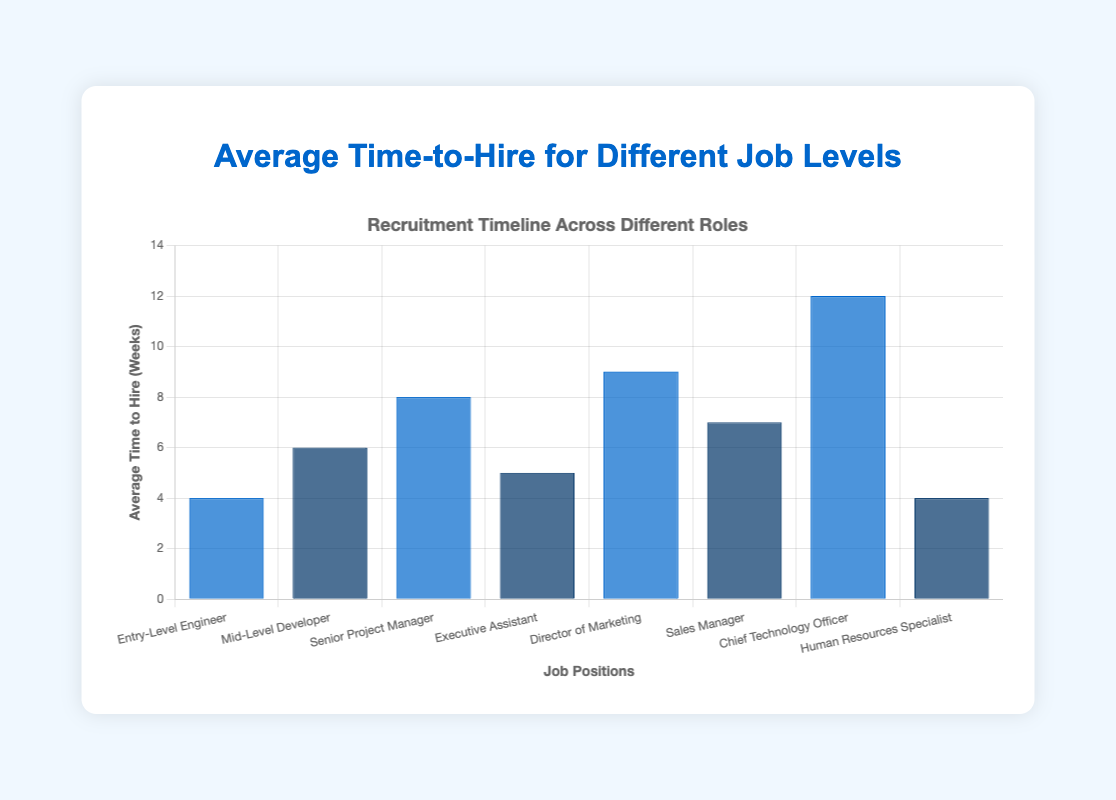What job level has the shortest average time-to-hire? The shortest average time-to-hire can be determined by identifying the job level with the smallest bar. "Entry-Level Engineer" and "Human Resources Specialist" both have the shortest average time-to-hire of 4 weeks.
Answer: Entry-Level Engineer, Human Resources Specialist Which job level has the longest average time-to-hire? The longest average time-to-hire can be determined by identifying the job level with the tallest bar. "Chief Technology Officer" has the longest average time-to-hire of 12 weeks.
Answer: Chief Technology Officer What is the average time-to-hire for the Senior Project Manager role? To find the average time-to-hire for the Senior Project Manager role, look at the height of the corresponding bar. The average time-to-hire for this role is 8 weeks.
Answer: 8 weeks Between the Executive Assistant and Director of Marketing, which role takes longer to hire? Compare the heights of the bars for Executive Assistant and Director of Marketing. The Director of Marketing takes longer to hire at 9 weeks, compared to the Executive Assistant at 5 weeks.
Answer: Director of Marketing What is the total time-to-hire for all the job levels combined? Sum the average time-to-hire for all job levels: 4 (Entry-Level Engineer) + 6 (Mid-Level Developer) + 8 (Senior Project Manager) + 5 (Executive Assistant) + 9 (Director of Marketing) + 7 (Sales Manager) + 12 (Chief Technology Officer) + 4 (Human Resources Specialist) = 55 weeks in total.
Answer: 55 weeks Which job level has more average time-to-hire, Sales Manager or Mid-Level Developer? Compare the heights of the bars for Sales Manager and Mid-Level Developer. Sales Manager has an average time-to-hire of 7 weeks, while Mid-Level Developer has 6 weeks. Therefore, Sales Manager has more time-to-hire.
Answer: Sales Manager How many roles have an average time-to-hire greater than 6 weeks? Count the number of job levels with bars taller than the height representing 6 weeks. The roles with an average time-to-hire greater than 6 weeks are Senior Project Manager (8 weeks), Director of Marketing (9 weeks), Sales Manager (7 weeks), and Chief Technology Officer (12 weeks). There are 4 roles in total.
Answer: 4 roles What is the difference in average time-to-hire between the Entry-Level Engineer and Chief Technology Officer roles? Subtract the average time-to-hire of the Entry-Level Engineer (4 weeks) from that of the Chief Technology Officer (12 weeks). The difference is 12 - 4 = 8 weeks.
Answer: 8 weeks Which roles have bars colored in blue? Identify the roles by their bar color. The roles with blue bars are Entry-Level Engineer (4 weeks), Senior Project Manager (8 weeks), Director of Marketing (9 weeks), and Chief Technology Officer (12 weeks).
Answer: Entry-Level Engineer, Senior Project Manager, Director of Marketing, Chief Technology Officer 